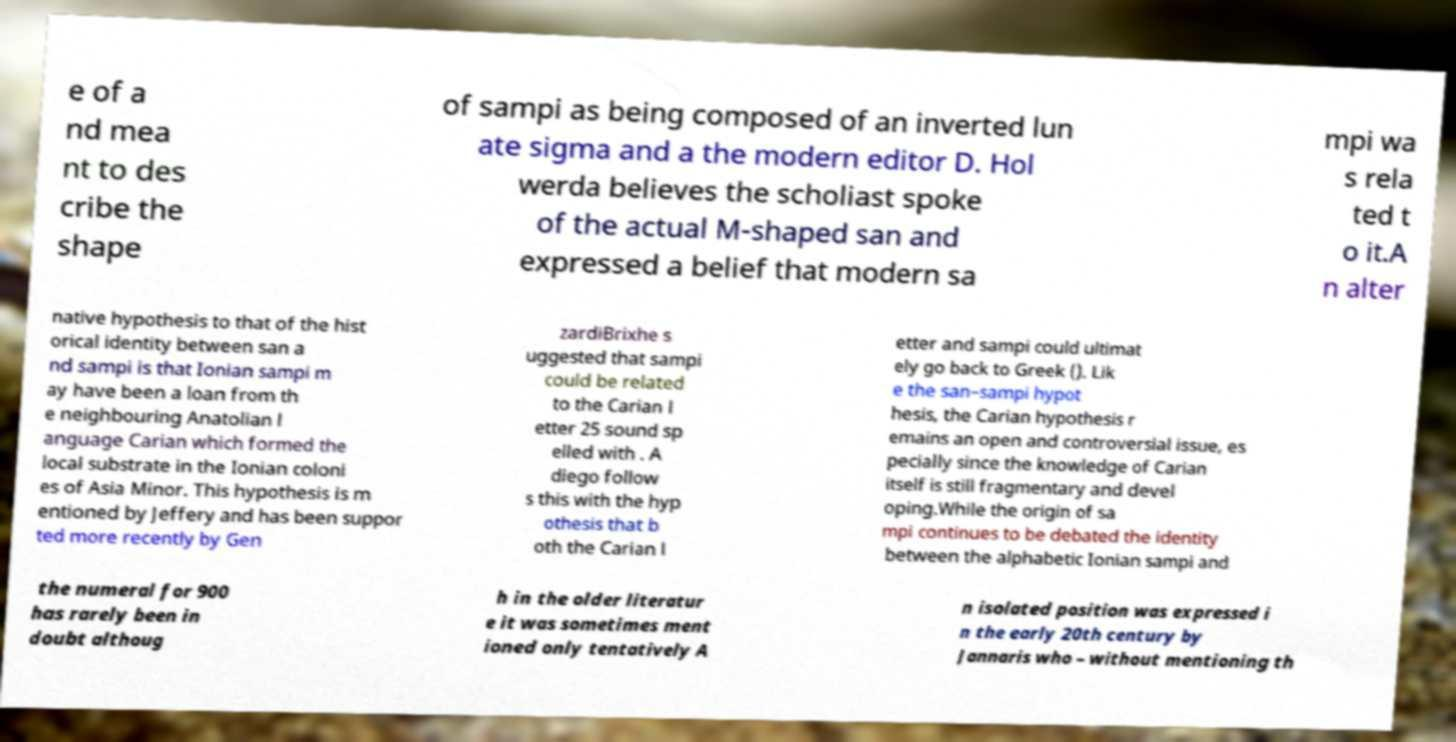There's text embedded in this image that I need extracted. Can you transcribe it verbatim? e of a nd mea nt to des cribe the shape of sampi as being composed of an inverted lun ate sigma and a the modern editor D. Hol werda believes the scholiast spoke of the actual M-shaped san and expressed a belief that modern sa mpi wa s rela ted t o it.A n alter native hypothesis to that of the hist orical identity between san a nd sampi is that Ionian sampi m ay have been a loan from th e neighbouring Anatolian l anguage Carian which formed the local substrate in the Ionian coloni es of Asia Minor. This hypothesis is m entioned by Jeffery and has been suppor ted more recently by Gen zardiBrixhe s uggested that sampi could be related to the Carian l etter 25 sound sp elled with . A diego follow s this with the hyp othesis that b oth the Carian l etter and sampi could ultimat ely go back to Greek (). Lik e the san–sampi hypot hesis, the Carian hypothesis r emains an open and controversial issue, es pecially since the knowledge of Carian itself is still fragmentary and devel oping.While the origin of sa mpi continues to be debated the identity between the alphabetic Ionian sampi and the numeral for 900 has rarely been in doubt althoug h in the older literatur e it was sometimes ment ioned only tentatively A n isolated position was expressed i n the early 20th century by Jannaris who – without mentioning th 